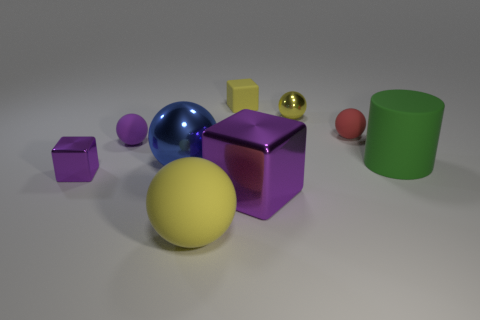What is the color of the large sphere that is made of the same material as the small red ball?
Provide a succinct answer. Yellow. Do the rubber thing to the left of the large blue sphere and the large shiny thing that is on the right side of the big yellow thing have the same shape?
Make the answer very short. No. What number of rubber things are either cylinders or purple things?
Your response must be concise. 2. What material is the block that is the same color as the tiny metal ball?
Your answer should be compact. Rubber. Is there any other thing that is the same shape as the large blue object?
Keep it short and to the point. Yes. There is a yellow object that is behind the yellow metal ball; what is it made of?
Your answer should be compact. Rubber. Are the yellow object that is in front of the large green rubber object and the big green cylinder made of the same material?
Offer a terse response. Yes. What number of objects are either tiny purple spheres or metallic balls that are behind the purple rubber thing?
Offer a terse response. 2. What size is the blue metallic object that is the same shape as the small purple matte thing?
Your answer should be compact. Large. Is there any other thing that has the same size as the purple ball?
Keep it short and to the point. Yes. 